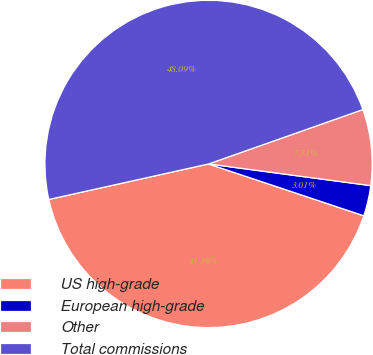Convert chart to OTSL. <chart><loc_0><loc_0><loc_500><loc_500><pie_chart><fcel>US high-grade<fcel>European high-grade<fcel>Other<fcel>Total commissions<nl><fcel>41.39%<fcel>3.01%<fcel>7.51%<fcel>48.09%<nl></chart> 